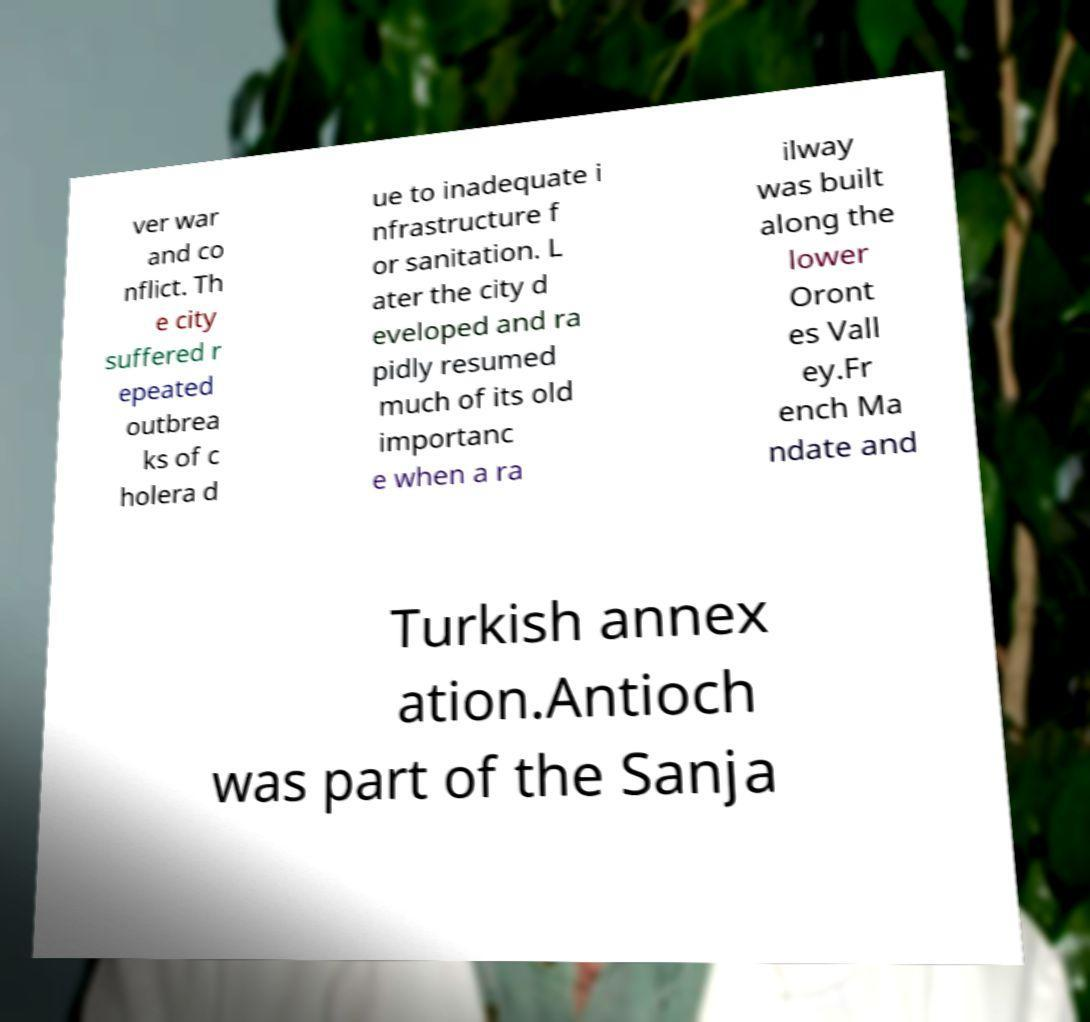Please read and relay the text visible in this image. What does it say? ver war and co nflict. Th e city suffered r epeated outbrea ks of c holera d ue to inadequate i nfrastructure f or sanitation. L ater the city d eveloped and ra pidly resumed much of its old importanc e when a ra ilway was built along the lower Oront es Vall ey.Fr ench Ma ndate and Turkish annex ation.Antioch was part of the Sanja 